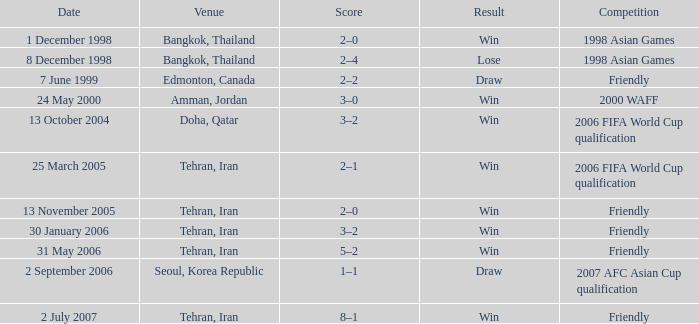Which event of rivalry was held on the 13th of november, 2005? Friendly. 